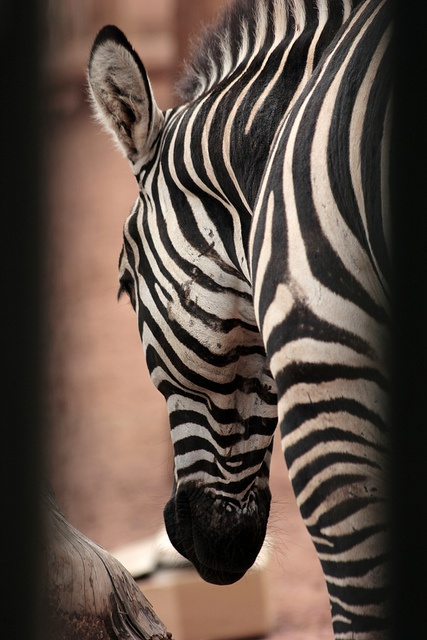Describe the objects in this image and their specific colors. I can see a zebra in black, gray, darkgray, and lightgray tones in this image. 